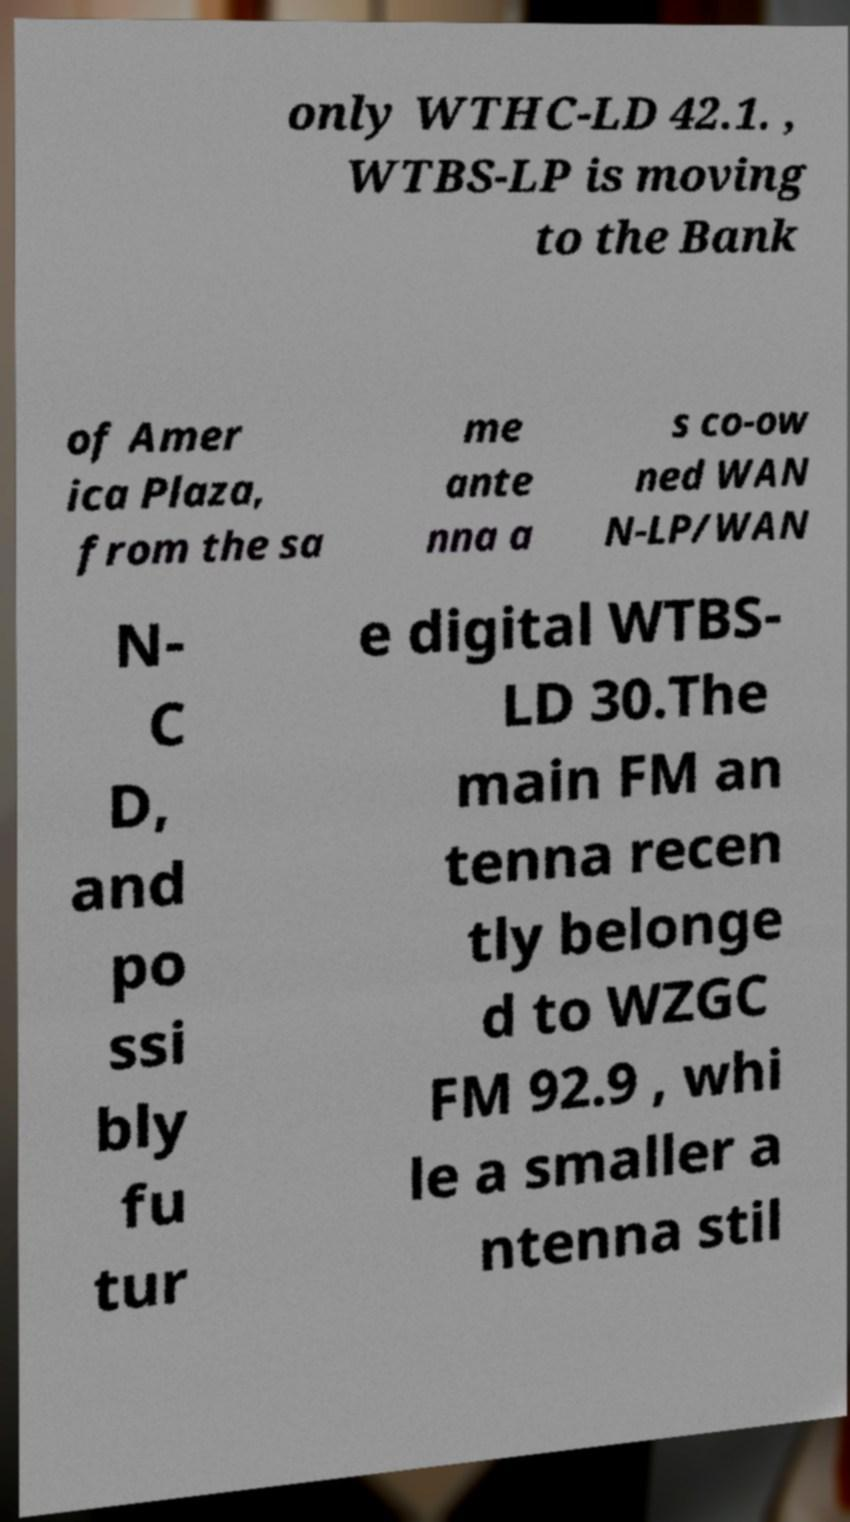For documentation purposes, I need the text within this image transcribed. Could you provide that? only WTHC-LD 42.1. , WTBS-LP is moving to the Bank of Amer ica Plaza, from the sa me ante nna a s co-ow ned WAN N-LP/WAN N- C D, and po ssi bly fu tur e digital WTBS- LD 30.The main FM an tenna recen tly belonge d to WZGC FM 92.9 , whi le a smaller a ntenna stil 